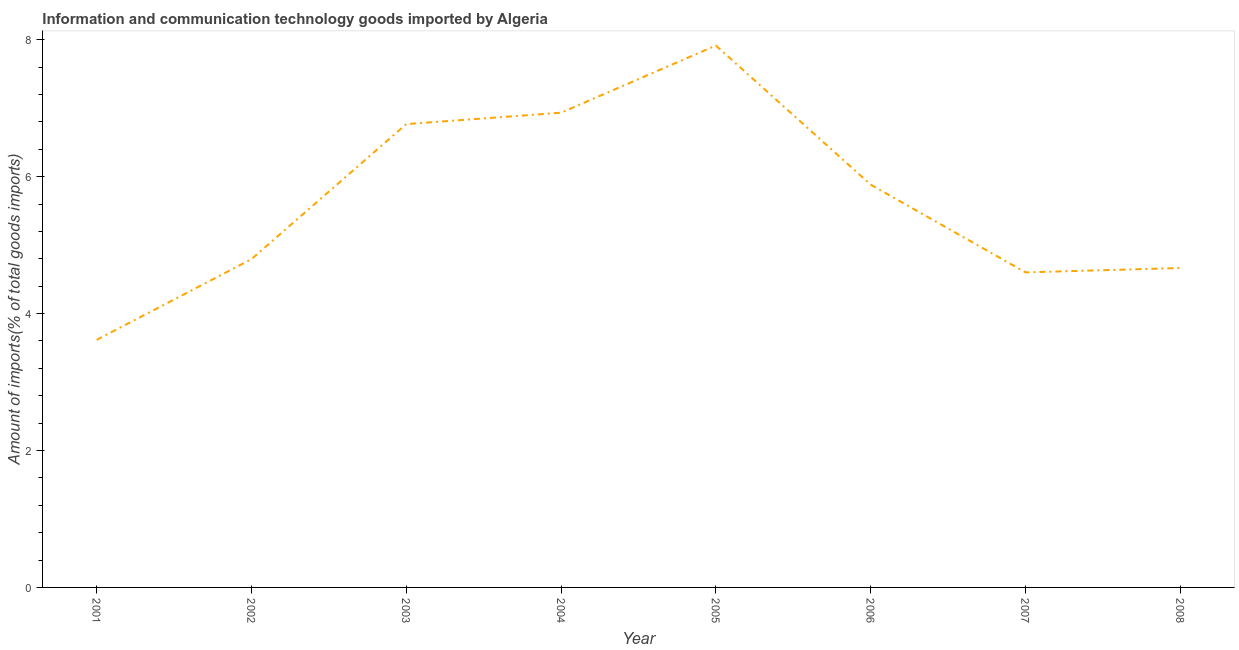What is the amount of ict goods imports in 2005?
Provide a succinct answer. 7.92. Across all years, what is the maximum amount of ict goods imports?
Provide a short and direct response. 7.92. Across all years, what is the minimum amount of ict goods imports?
Provide a succinct answer. 3.62. What is the sum of the amount of ict goods imports?
Provide a succinct answer. 45.18. What is the difference between the amount of ict goods imports in 2001 and 2008?
Your answer should be compact. -1.05. What is the average amount of ict goods imports per year?
Keep it short and to the point. 5.65. What is the median amount of ict goods imports?
Offer a very short reply. 5.34. Do a majority of the years between 2004 and 2007 (inclusive) have amount of ict goods imports greater than 3.6 %?
Offer a very short reply. Yes. What is the ratio of the amount of ict goods imports in 2006 to that in 2008?
Offer a very short reply. 1.26. What is the difference between the highest and the second highest amount of ict goods imports?
Your response must be concise. 0.98. What is the difference between the highest and the lowest amount of ict goods imports?
Make the answer very short. 4.3. How many lines are there?
Your answer should be very brief. 1. What is the difference between two consecutive major ticks on the Y-axis?
Your answer should be compact. 2. Does the graph contain grids?
Your answer should be compact. No. What is the title of the graph?
Make the answer very short. Information and communication technology goods imported by Algeria. What is the label or title of the Y-axis?
Provide a short and direct response. Amount of imports(% of total goods imports). What is the Amount of imports(% of total goods imports) of 2001?
Offer a terse response. 3.62. What is the Amount of imports(% of total goods imports) of 2002?
Your response must be concise. 4.79. What is the Amount of imports(% of total goods imports) in 2003?
Provide a succinct answer. 6.77. What is the Amount of imports(% of total goods imports) in 2004?
Provide a short and direct response. 6.93. What is the Amount of imports(% of total goods imports) in 2005?
Your answer should be very brief. 7.92. What is the Amount of imports(% of total goods imports) in 2006?
Your answer should be compact. 5.88. What is the Amount of imports(% of total goods imports) in 2007?
Make the answer very short. 4.6. What is the Amount of imports(% of total goods imports) in 2008?
Make the answer very short. 4.67. What is the difference between the Amount of imports(% of total goods imports) in 2001 and 2002?
Your answer should be compact. -1.18. What is the difference between the Amount of imports(% of total goods imports) in 2001 and 2003?
Provide a short and direct response. -3.15. What is the difference between the Amount of imports(% of total goods imports) in 2001 and 2004?
Ensure brevity in your answer.  -3.32. What is the difference between the Amount of imports(% of total goods imports) in 2001 and 2005?
Your response must be concise. -4.3. What is the difference between the Amount of imports(% of total goods imports) in 2001 and 2006?
Make the answer very short. -2.27. What is the difference between the Amount of imports(% of total goods imports) in 2001 and 2007?
Offer a very short reply. -0.99. What is the difference between the Amount of imports(% of total goods imports) in 2001 and 2008?
Give a very brief answer. -1.05. What is the difference between the Amount of imports(% of total goods imports) in 2002 and 2003?
Provide a short and direct response. -1.97. What is the difference between the Amount of imports(% of total goods imports) in 2002 and 2004?
Offer a terse response. -2.14. What is the difference between the Amount of imports(% of total goods imports) in 2002 and 2005?
Your answer should be compact. -3.12. What is the difference between the Amount of imports(% of total goods imports) in 2002 and 2006?
Offer a very short reply. -1.09. What is the difference between the Amount of imports(% of total goods imports) in 2002 and 2007?
Make the answer very short. 0.19. What is the difference between the Amount of imports(% of total goods imports) in 2002 and 2008?
Offer a terse response. 0.13. What is the difference between the Amount of imports(% of total goods imports) in 2003 and 2004?
Make the answer very short. -0.17. What is the difference between the Amount of imports(% of total goods imports) in 2003 and 2005?
Ensure brevity in your answer.  -1.15. What is the difference between the Amount of imports(% of total goods imports) in 2003 and 2006?
Offer a very short reply. 0.88. What is the difference between the Amount of imports(% of total goods imports) in 2003 and 2007?
Provide a short and direct response. 2.17. What is the difference between the Amount of imports(% of total goods imports) in 2003 and 2008?
Ensure brevity in your answer.  2.1. What is the difference between the Amount of imports(% of total goods imports) in 2004 and 2005?
Offer a terse response. -0.98. What is the difference between the Amount of imports(% of total goods imports) in 2004 and 2006?
Provide a short and direct response. 1.05. What is the difference between the Amount of imports(% of total goods imports) in 2004 and 2007?
Keep it short and to the point. 2.33. What is the difference between the Amount of imports(% of total goods imports) in 2004 and 2008?
Offer a very short reply. 2.27. What is the difference between the Amount of imports(% of total goods imports) in 2005 and 2006?
Your answer should be very brief. 2.03. What is the difference between the Amount of imports(% of total goods imports) in 2005 and 2007?
Ensure brevity in your answer.  3.31. What is the difference between the Amount of imports(% of total goods imports) in 2005 and 2008?
Give a very brief answer. 3.25. What is the difference between the Amount of imports(% of total goods imports) in 2006 and 2007?
Give a very brief answer. 1.28. What is the difference between the Amount of imports(% of total goods imports) in 2006 and 2008?
Provide a short and direct response. 1.22. What is the difference between the Amount of imports(% of total goods imports) in 2007 and 2008?
Provide a succinct answer. -0.06. What is the ratio of the Amount of imports(% of total goods imports) in 2001 to that in 2002?
Your response must be concise. 0.75. What is the ratio of the Amount of imports(% of total goods imports) in 2001 to that in 2003?
Make the answer very short. 0.53. What is the ratio of the Amount of imports(% of total goods imports) in 2001 to that in 2004?
Offer a very short reply. 0.52. What is the ratio of the Amount of imports(% of total goods imports) in 2001 to that in 2005?
Offer a terse response. 0.46. What is the ratio of the Amount of imports(% of total goods imports) in 2001 to that in 2006?
Offer a terse response. 0.61. What is the ratio of the Amount of imports(% of total goods imports) in 2001 to that in 2007?
Your answer should be very brief. 0.79. What is the ratio of the Amount of imports(% of total goods imports) in 2001 to that in 2008?
Keep it short and to the point. 0.78. What is the ratio of the Amount of imports(% of total goods imports) in 2002 to that in 2003?
Keep it short and to the point. 0.71. What is the ratio of the Amount of imports(% of total goods imports) in 2002 to that in 2004?
Keep it short and to the point. 0.69. What is the ratio of the Amount of imports(% of total goods imports) in 2002 to that in 2005?
Ensure brevity in your answer.  0.61. What is the ratio of the Amount of imports(% of total goods imports) in 2002 to that in 2006?
Provide a short and direct response. 0.81. What is the ratio of the Amount of imports(% of total goods imports) in 2002 to that in 2007?
Keep it short and to the point. 1.04. What is the ratio of the Amount of imports(% of total goods imports) in 2002 to that in 2008?
Offer a very short reply. 1.03. What is the ratio of the Amount of imports(% of total goods imports) in 2003 to that in 2004?
Provide a short and direct response. 0.98. What is the ratio of the Amount of imports(% of total goods imports) in 2003 to that in 2005?
Make the answer very short. 0.85. What is the ratio of the Amount of imports(% of total goods imports) in 2003 to that in 2006?
Provide a short and direct response. 1.15. What is the ratio of the Amount of imports(% of total goods imports) in 2003 to that in 2007?
Your response must be concise. 1.47. What is the ratio of the Amount of imports(% of total goods imports) in 2003 to that in 2008?
Your response must be concise. 1.45. What is the ratio of the Amount of imports(% of total goods imports) in 2004 to that in 2005?
Your answer should be compact. 0.88. What is the ratio of the Amount of imports(% of total goods imports) in 2004 to that in 2006?
Keep it short and to the point. 1.18. What is the ratio of the Amount of imports(% of total goods imports) in 2004 to that in 2007?
Give a very brief answer. 1.51. What is the ratio of the Amount of imports(% of total goods imports) in 2004 to that in 2008?
Provide a succinct answer. 1.49. What is the ratio of the Amount of imports(% of total goods imports) in 2005 to that in 2006?
Your answer should be compact. 1.34. What is the ratio of the Amount of imports(% of total goods imports) in 2005 to that in 2007?
Provide a succinct answer. 1.72. What is the ratio of the Amount of imports(% of total goods imports) in 2005 to that in 2008?
Offer a terse response. 1.7. What is the ratio of the Amount of imports(% of total goods imports) in 2006 to that in 2007?
Offer a terse response. 1.28. What is the ratio of the Amount of imports(% of total goods imports) in 2006 to that in 2008?
Your response must be concise. 1.26. 